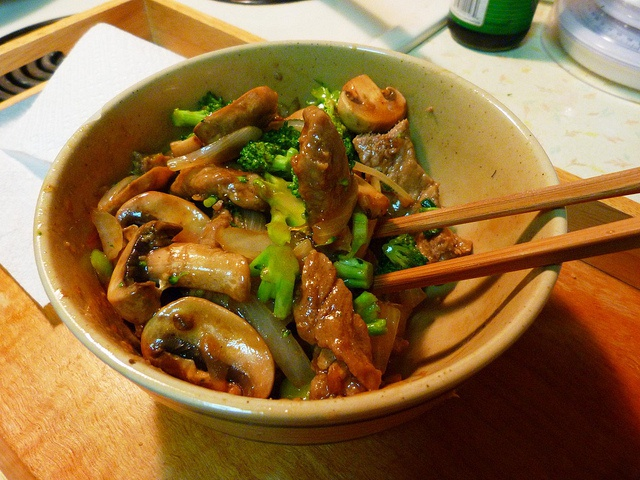Describe the objects in this image and their specific colors. I can see dining table in black, maroon, ivory, and olive tones, bowl in black, maroon, and olive tones, broccoli in darkgreen, black, and olive tones, bottle in darkgreen, black, darkgray, and beige tones, and broccoli in black, olive, and darkgreen tones in this image. 